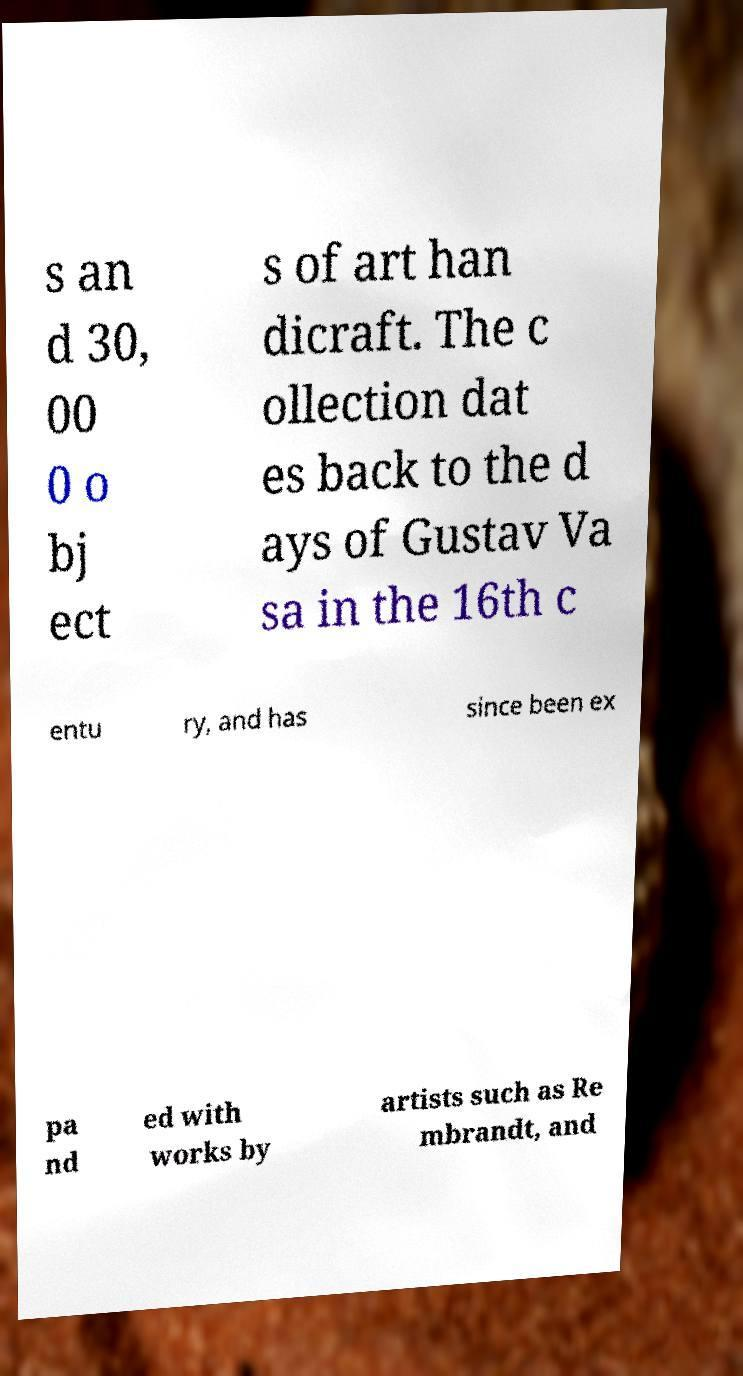Can you accurately transcribe the text from the provided image for me? s an d 30, 00 0 o bj ect s of art han dicraft. The c ollection dat es back to the d ays of Gustav Va sa in the 16th c entu ry, and has since been ex pa nd ed with works by artists such as Re mbrandt, and 